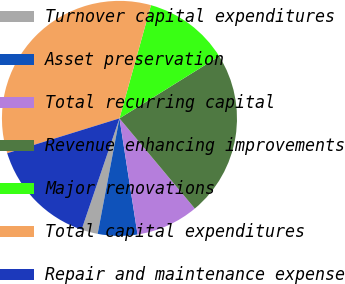<chart> <loc_0><loc_0><loc_500><loc_500><pie_chart><fcel>Turnover capital expenditures<fcel>Asset preservation<fcel>Total recurring capital<fcel>Revenue enhancing improvements<fcel>Major renovations<fcel>Total capital expenditures<fcel>Repair and maintenance expense<nl><fcel>2.25%<fcel>5.43%<fcel>8.62%<fcel>22.79%<fcel>11.81%<fcel>34.11%<fcel>14.99%<nl></chart> 